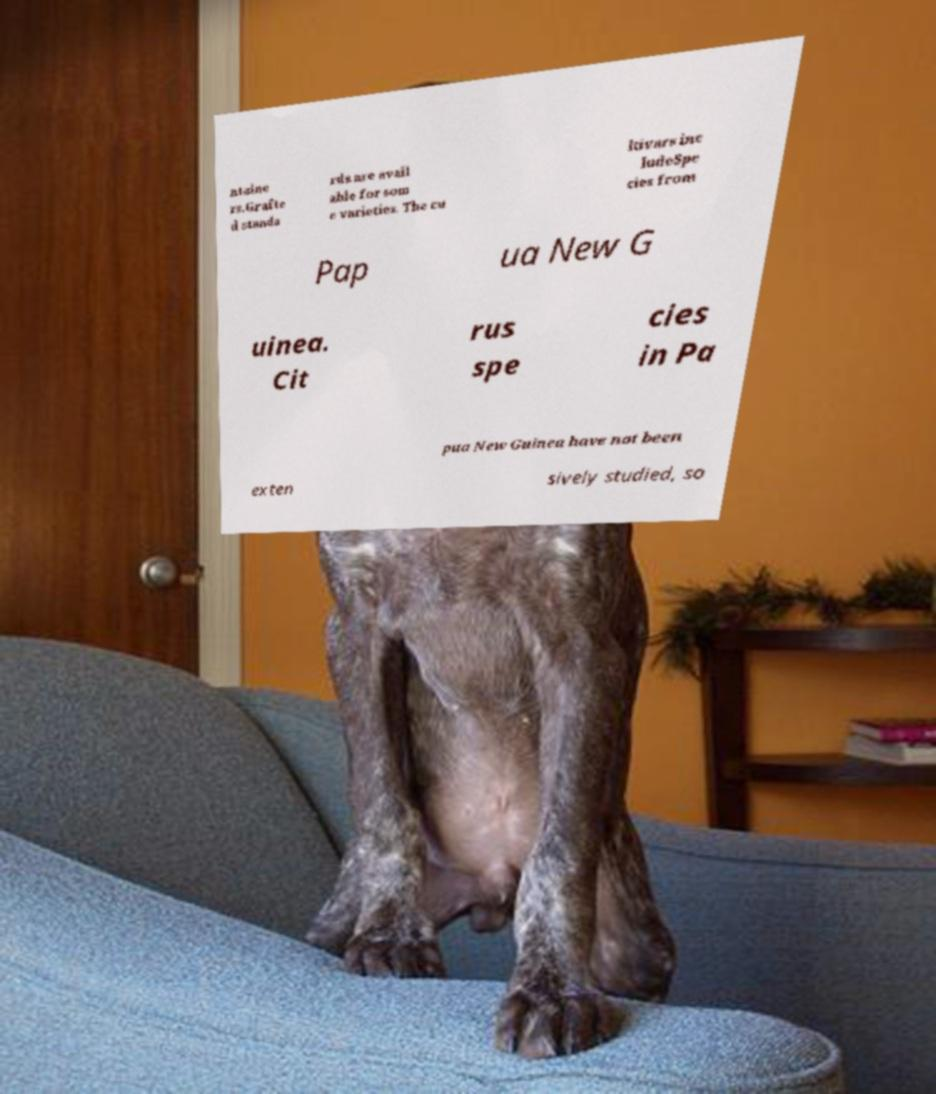There's text embedded in this image that I need extracted. Can you transcribe it verbatim? ntaine rs.Grafte d standa rds are avail able for som e varieties. The cu ltivars inc ludeSpe cies from Pap ua New G uinea. Cit rus spe cies in Pa pua New Guinea have not been exten sively studied, so 